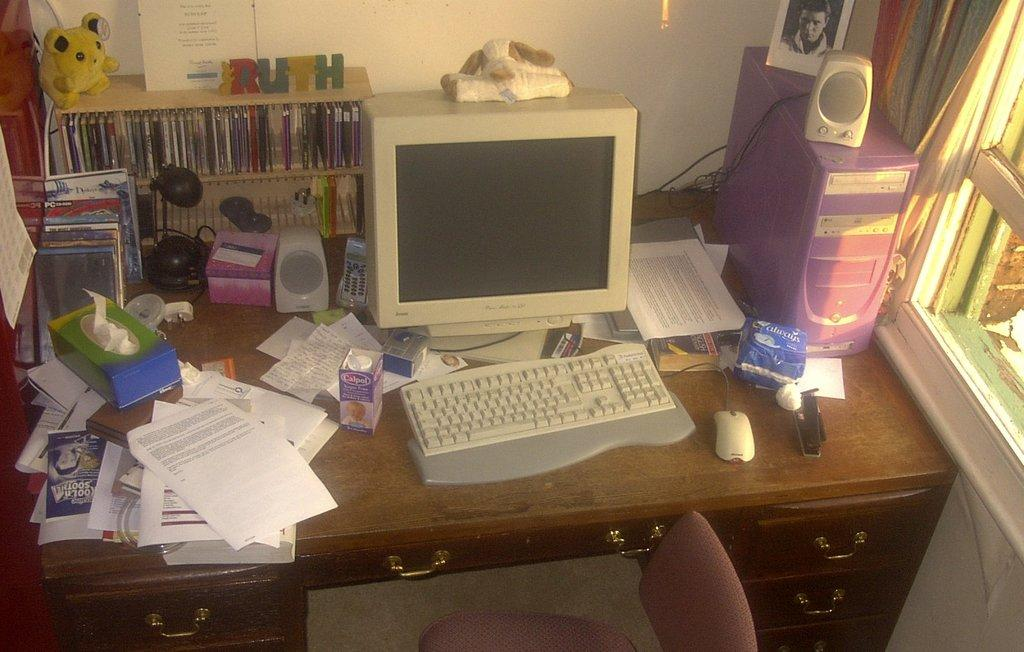<image>
Share a concise interpretation of the image provided. A desk containing various objects including the word Ruth spelled out with block letters. 